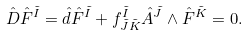<formula> <loc_0><loc_0><loc_500><loc_500>\hat { D } \hat { F } ^ { \tilde { I } } = \hat { d } \hat { F } ^ { \tilde { I } } + f ^ { \tilde { I } } _ { \tilde { J } \tilde { K } } \hat { A } ^ { \tilde { J } } \wedge \hat { F } ^ { \tilde { K } } = 0 .</formula> 